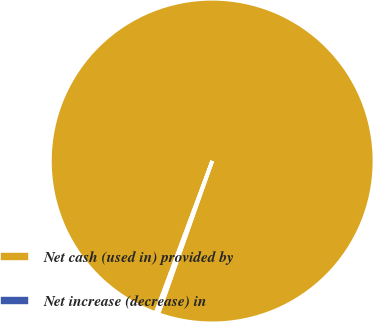<chart> <loc_0><loc_0><loc_500><loc_500><pie_chart><fcel>Net cash (used in) provided by<fcel>Net increase (decrease) in<nl><fcel>99.71%<fcel>0.29%<nl></chart> 